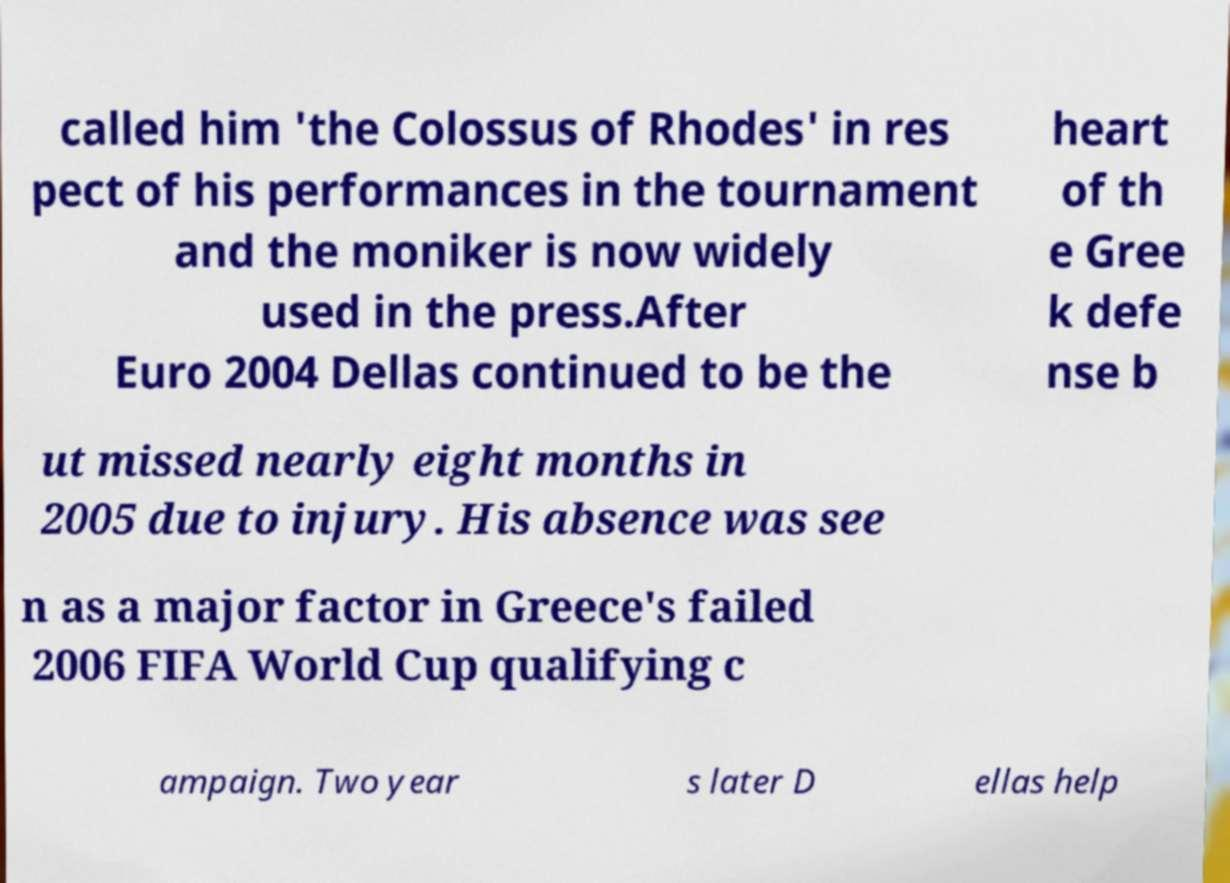Can you read and provide the text displayed in the image?This photo seems to have some interesting text. Can you extract and type it out for me? called him 'the Colossus of Rhodes' in res pect of his performances in the tournament and the moniker is now widely used in the press.After Euro 2004 Dellas continued to be the heart of th e Gree k defe nse b ut missed nearly eight months in 2005 due to injury. His absence was see n as a major factor in Greece's failed 2006 FIFA World Cup qualifying c ampaign. Two year s later D ellas help 